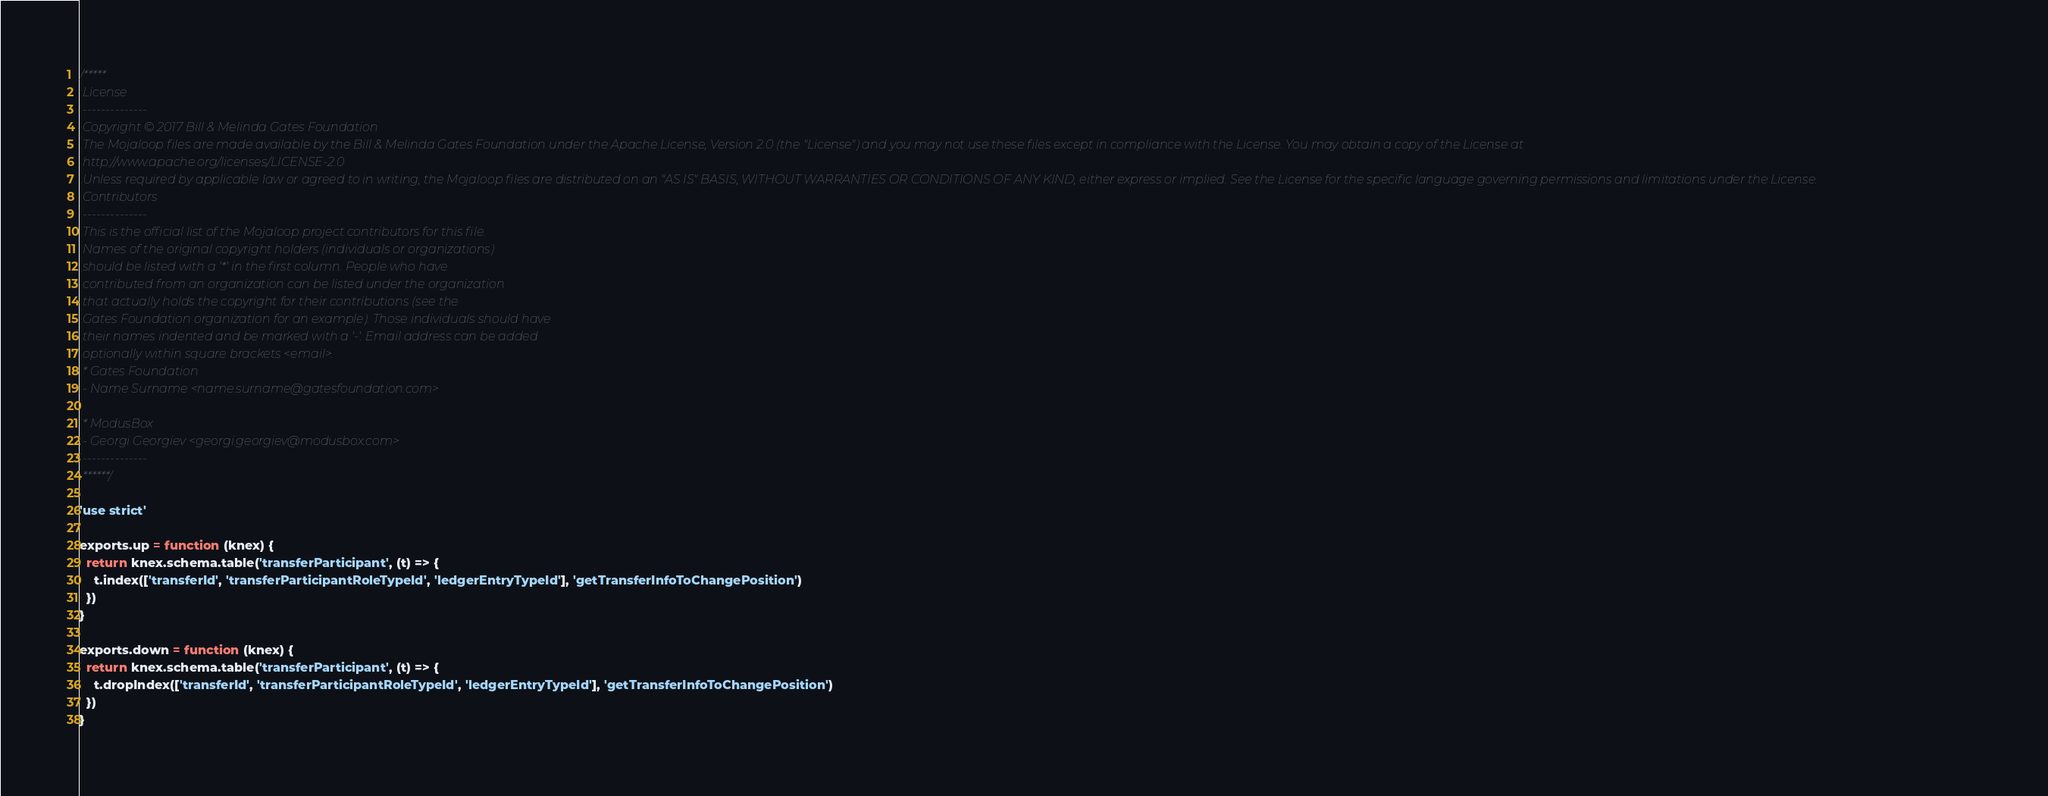Convert code to text. <code><loc_0><loc_0><loc_500><loc_500><_JavaScript_>/*****
 License
 --------------
 Copyright © 2017 Bill & Melinda Gates Foundation
 The Mojaloop files are made available by the Bill & Melinda Gates Foundation under the Apache License, Version 2.0 (the "License") and you may not use these files except in compliance with the License. You may obtain a copy of the License at
 http://www.apache.org/licenses/LICENSE-2.0
 Unless required by applicable law or agreed to in writing, the Mojaloop files are distributed on an "AS IS" BASIS, WITHOUT WARRANTIES OR CONDITIONS OF ANY KIND, either express or implied. See the License for the specific language governing permissions and limitations under the License.
 Contributors
 --------------
 This is the official list of the Mojaloop project contributors for this file.
 Names of the original copyright holders (individuals or organizations)
 should be listed with a '*' in the first column. People who have
 contributed from an organization can be listed under the organization
 that actually holds the copyright for their contributions (see the
 Gates Foundation organization for an example). Those individuals should have
 their names indented and be marked with a '-'. Email address can be added
 optionally within square brackets <email>.
 * Gates Foundation
 - Name Surname <name.surname@gatesfoundation.com>

 * ModusBox
 - Georgi Georgiev <georgi.georgiev@modusbox.com>
 --------------
 ******/

'use strict'

exports.up = function (knex) {
  return knex.schema.table('transferParticipant', (t) => {
    t.index(['transferId', 'transferParticipantRoleTypeId', 'ledgerEntryTypeId'], 'getTransferInfoToChangePosition')
  })
}

exports.down = function (knex) {
  return knex.schema.table('transferParticipant', (t) => {
    t.dropIndex(['transferId', 'transferParticipantRoleTypeId', 'ledgerEntryTypeId'], 'getTransferInfoToChangePosition')
  })
}
</code> 